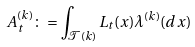<formula> <loc_0><loc_0><loc_500><loc_500>A ^ { ( k ) } _ { t } \colon = \int _ { { \mathcal { T } } ( k ) } L _ { t } ( x ) { \lambda } ^ { ( k ) } ( d x )</formula> 